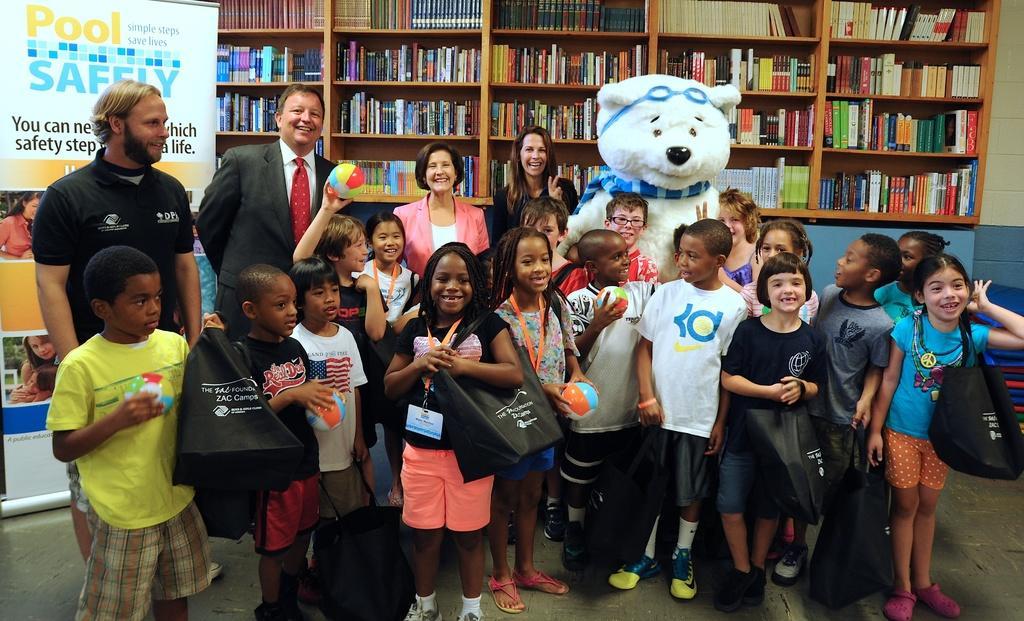Please provide a concise description of this image. In this picture, we can see a few people, and a few children, and we can see a person in a costume, we can see the floor, and some objects on the floor like poster, and we can see some object on the right corner, we can see the wall and a shelf attached to it, and we can see some books in a shelf. 